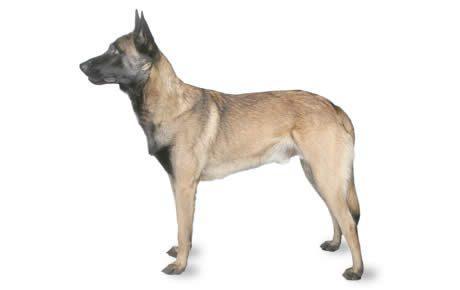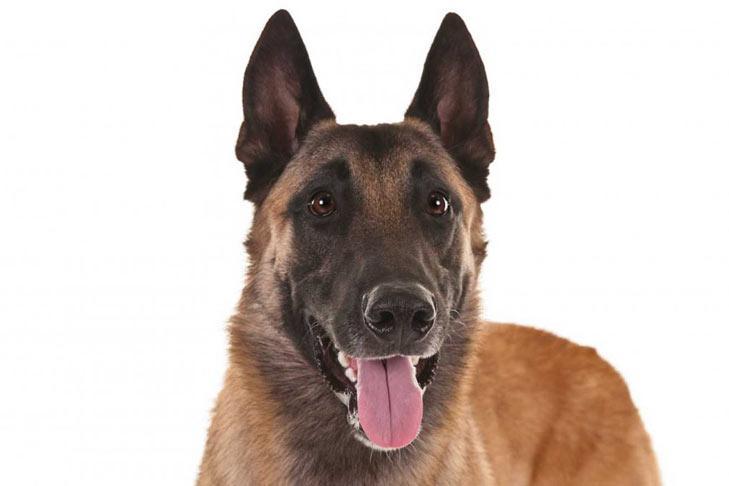The first image is the image on the left, the second image is the image on the right. Analyze the images presented: Is the assertion "A dog is pictured against a plain white backgroun." valid? Answer yes or no. Yes. 